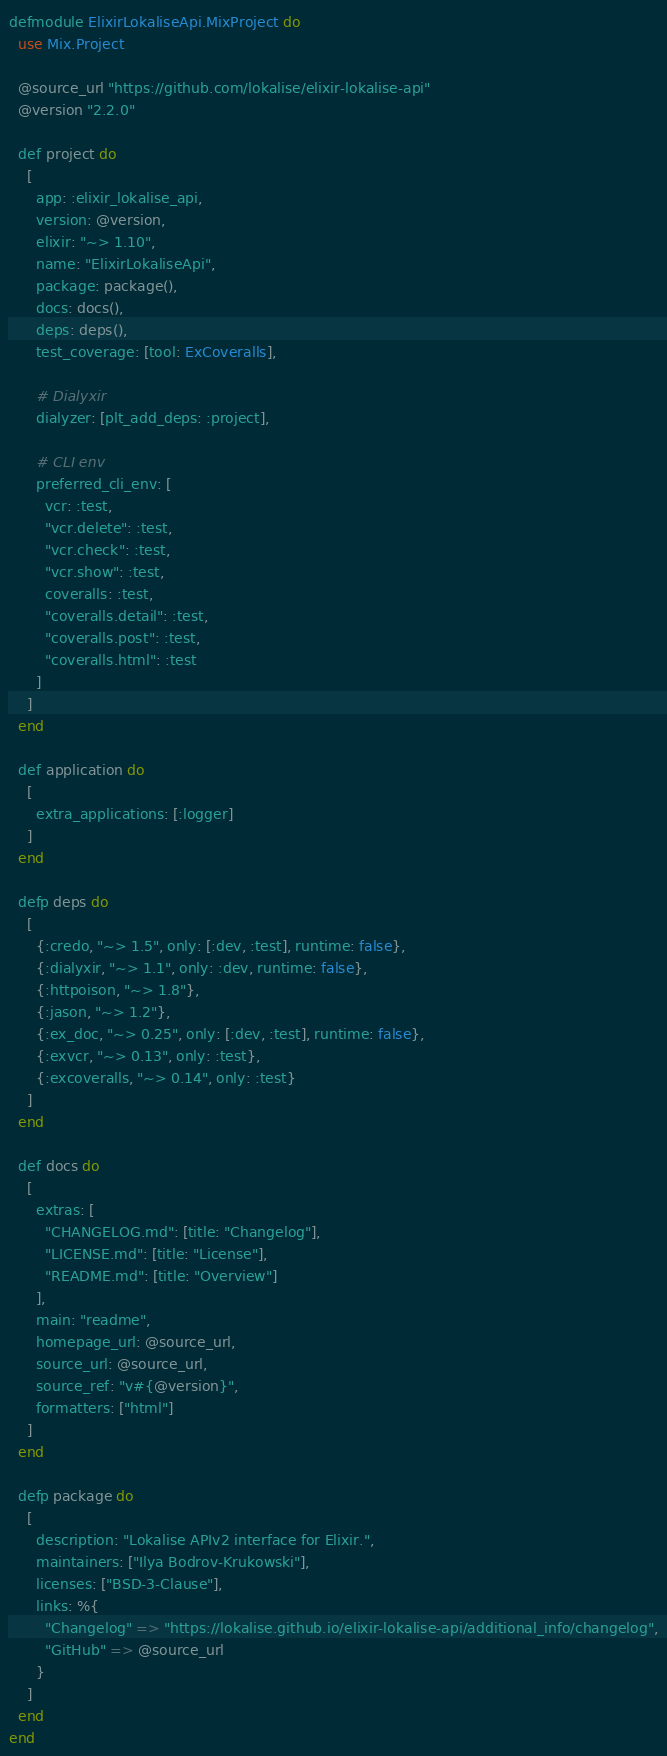Convert code to text. <code><loc_0><loc_0><loc_500><loc_500><_Elixir_>defmodule ElixirLokaliseApi.MixProject do
  use Mix.Project

  @source_url "https://github.com/lokalise/elixir-lokalise-api"
  @version "2.2.0"

  def project do
    [
      app: :elixir_lokalise_api,
      version: @version,
      elixir: "~> 1.10",
      name: "ElixirLokaliseApi",
      package: package(),
      docs: docs(),
      deps: deps(),
      test_coverage: [tool: ExCoveralls],

      # Dialyxir
      dialyzer: [plt_add_deps: :project],

      # CLI env
      preferred_cli_env: [
        vcr: :test,
        "vcr.delete": :test,
        "vcr.check": :test,
        "vcr.show": :test,
        coveralls: :test,
        "coveralls.detail": :test,
        "coveralls.post": :test,
        "coveralls.html": :test
      ]
    ]
  end

  def application do
    [
      extra_applications: [:logger]
    ]
  end

  defp deps do
    [
      {:credo, "~> 1.5", only: [:dev, :test], runtime: false},
      {:dialyxir, "~> 1.1", only: :dev, runtime: false},
      {:httpoison, "~> 1.8"},
      {:jason, "~> 1.2"},
      {:ex_doc, "~> 0.25", only: [:dev, :test], runtime: false},
      {:exvcr, "~> 0.13", only: :test},
      {:excoveralls, "~> 0.14", only: :test}
    ]
  end

  def docs do
    [
      extras: [
        "CHANGELOG.md": [title: "Changelog"],
        "LICENSE.md": [title: "License"],
        "README.md": [title: "Overview"]
      ],
      main: "readme",
      homepage_url: @source_url,
      source_url: @source_url,
      source_ref: "v#{@version}",
      formatters: ["html"]
    ]
  end

  defp package do
    [
      description: "Lokalise APIv2 interface for Elixir.",
      maintainers: ["Ilya Bodrov-Krukowski"],
      licenses: ["BSD-3-Clause"],
      links: %{
        "Changelog" => "https://lokalise.github.io/elixir-lokalise-api/additional_info/changelog",
        "GitHub" => @source_url
      }
    ]
  end
end
</code> 